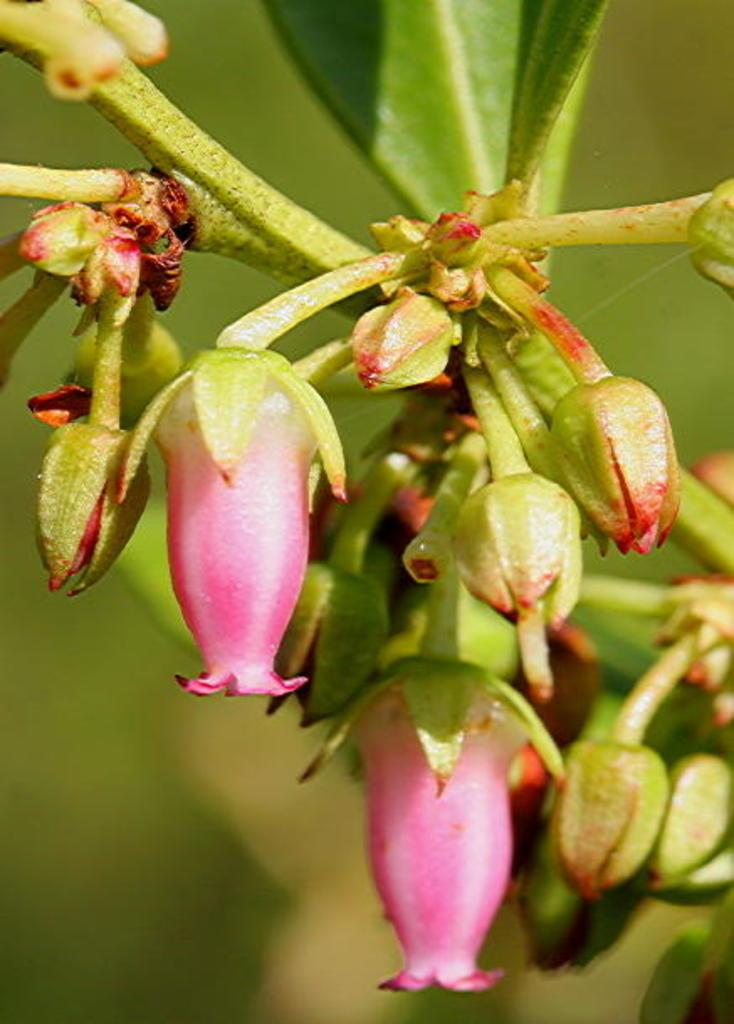What type of plants can be seen in the image? There are flowers in the image. Can you describe the stage of growth for some of the plants in the image? Yes, there are buds in the image, which are flowers in the early stages of development. What type of wax can be seen dripping from the tub in the image? There is no wax or tub present in the image; it features flowers and buds. 